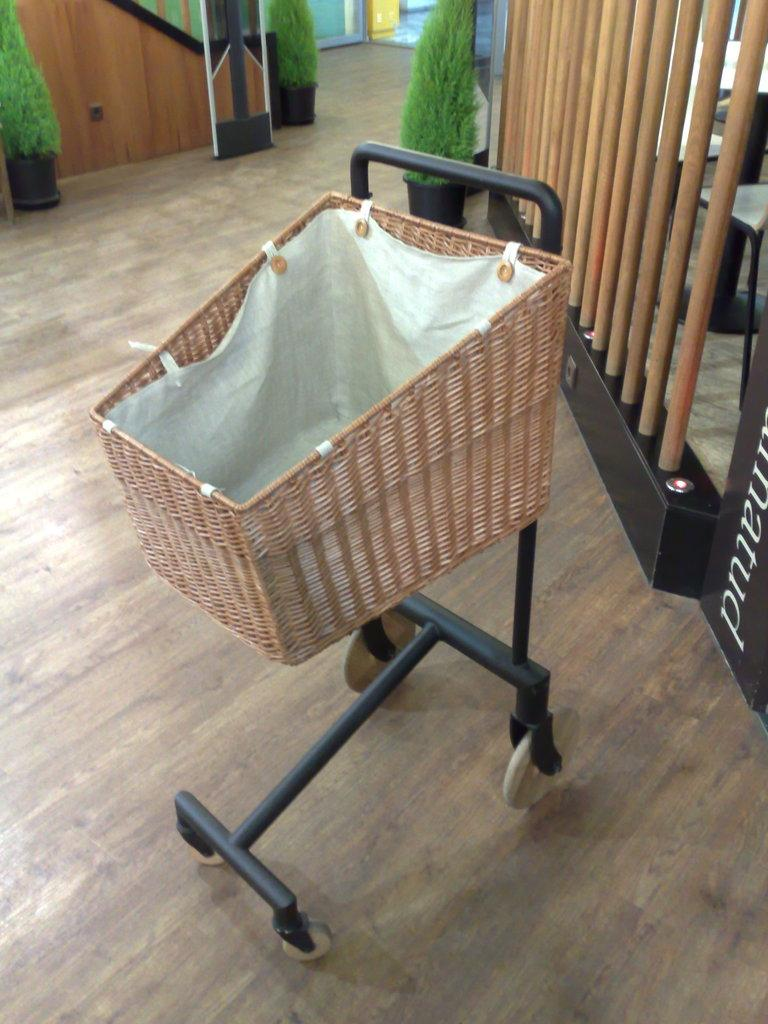What is the main object in the image? There is a trolley in the image. What is on top of the trolley? There is a white object on the trolley. What can be seen in the background of the image? There are plants in pots in the background of the image. Is there any text visible in the image? Yes, there is text visible in the image. What type of joke is being told by the duck in the image? There is no duck present in the image, so no joke can be attributed to a duck. 